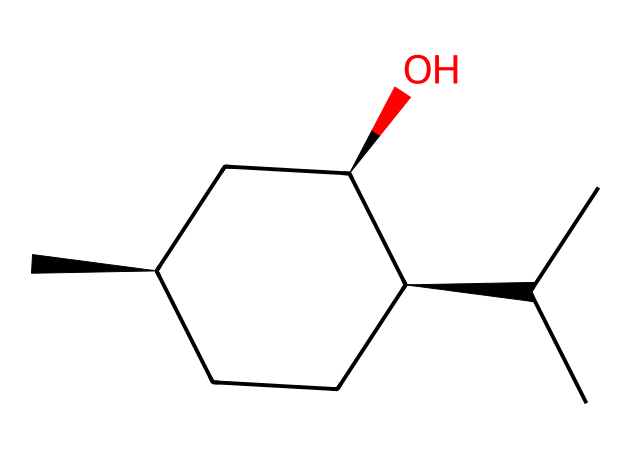How many carbon atoms are present in menthol? In the provided SMILES representation, count the "C" symbols, which represent carbon atoms. The structure includes 10 carbon atoms.
Answer: ten What is the number of hydroxyl groups in menthol? The hydroxyl group is represented by "O" followed by hydrogen atoms. In the given structure, there is one "O" indicating one hydroxyl group.
Answer: one What type of stereocenters are present in menthol? The stereocenters are denoted by the "@" symbols in the SMILES representation, showing the presence of three chiral centers (indicated by the two "@") in the compound.
Answer: chiral centers Which functional group characterizes menthol among organic compounds? The presence of the hydroxyl group ("-OH") indicates that menthol is classified as an alcohol.
Answer: alcohol How many degrees of unsaturation does menthol have? Count the total number of rings and multiple bonds (not present in this case) in the structure. Here, menthol has a saturated structure with no double bonds or rings, resulting in zero degrees of unsaturation.
Answer: zero 